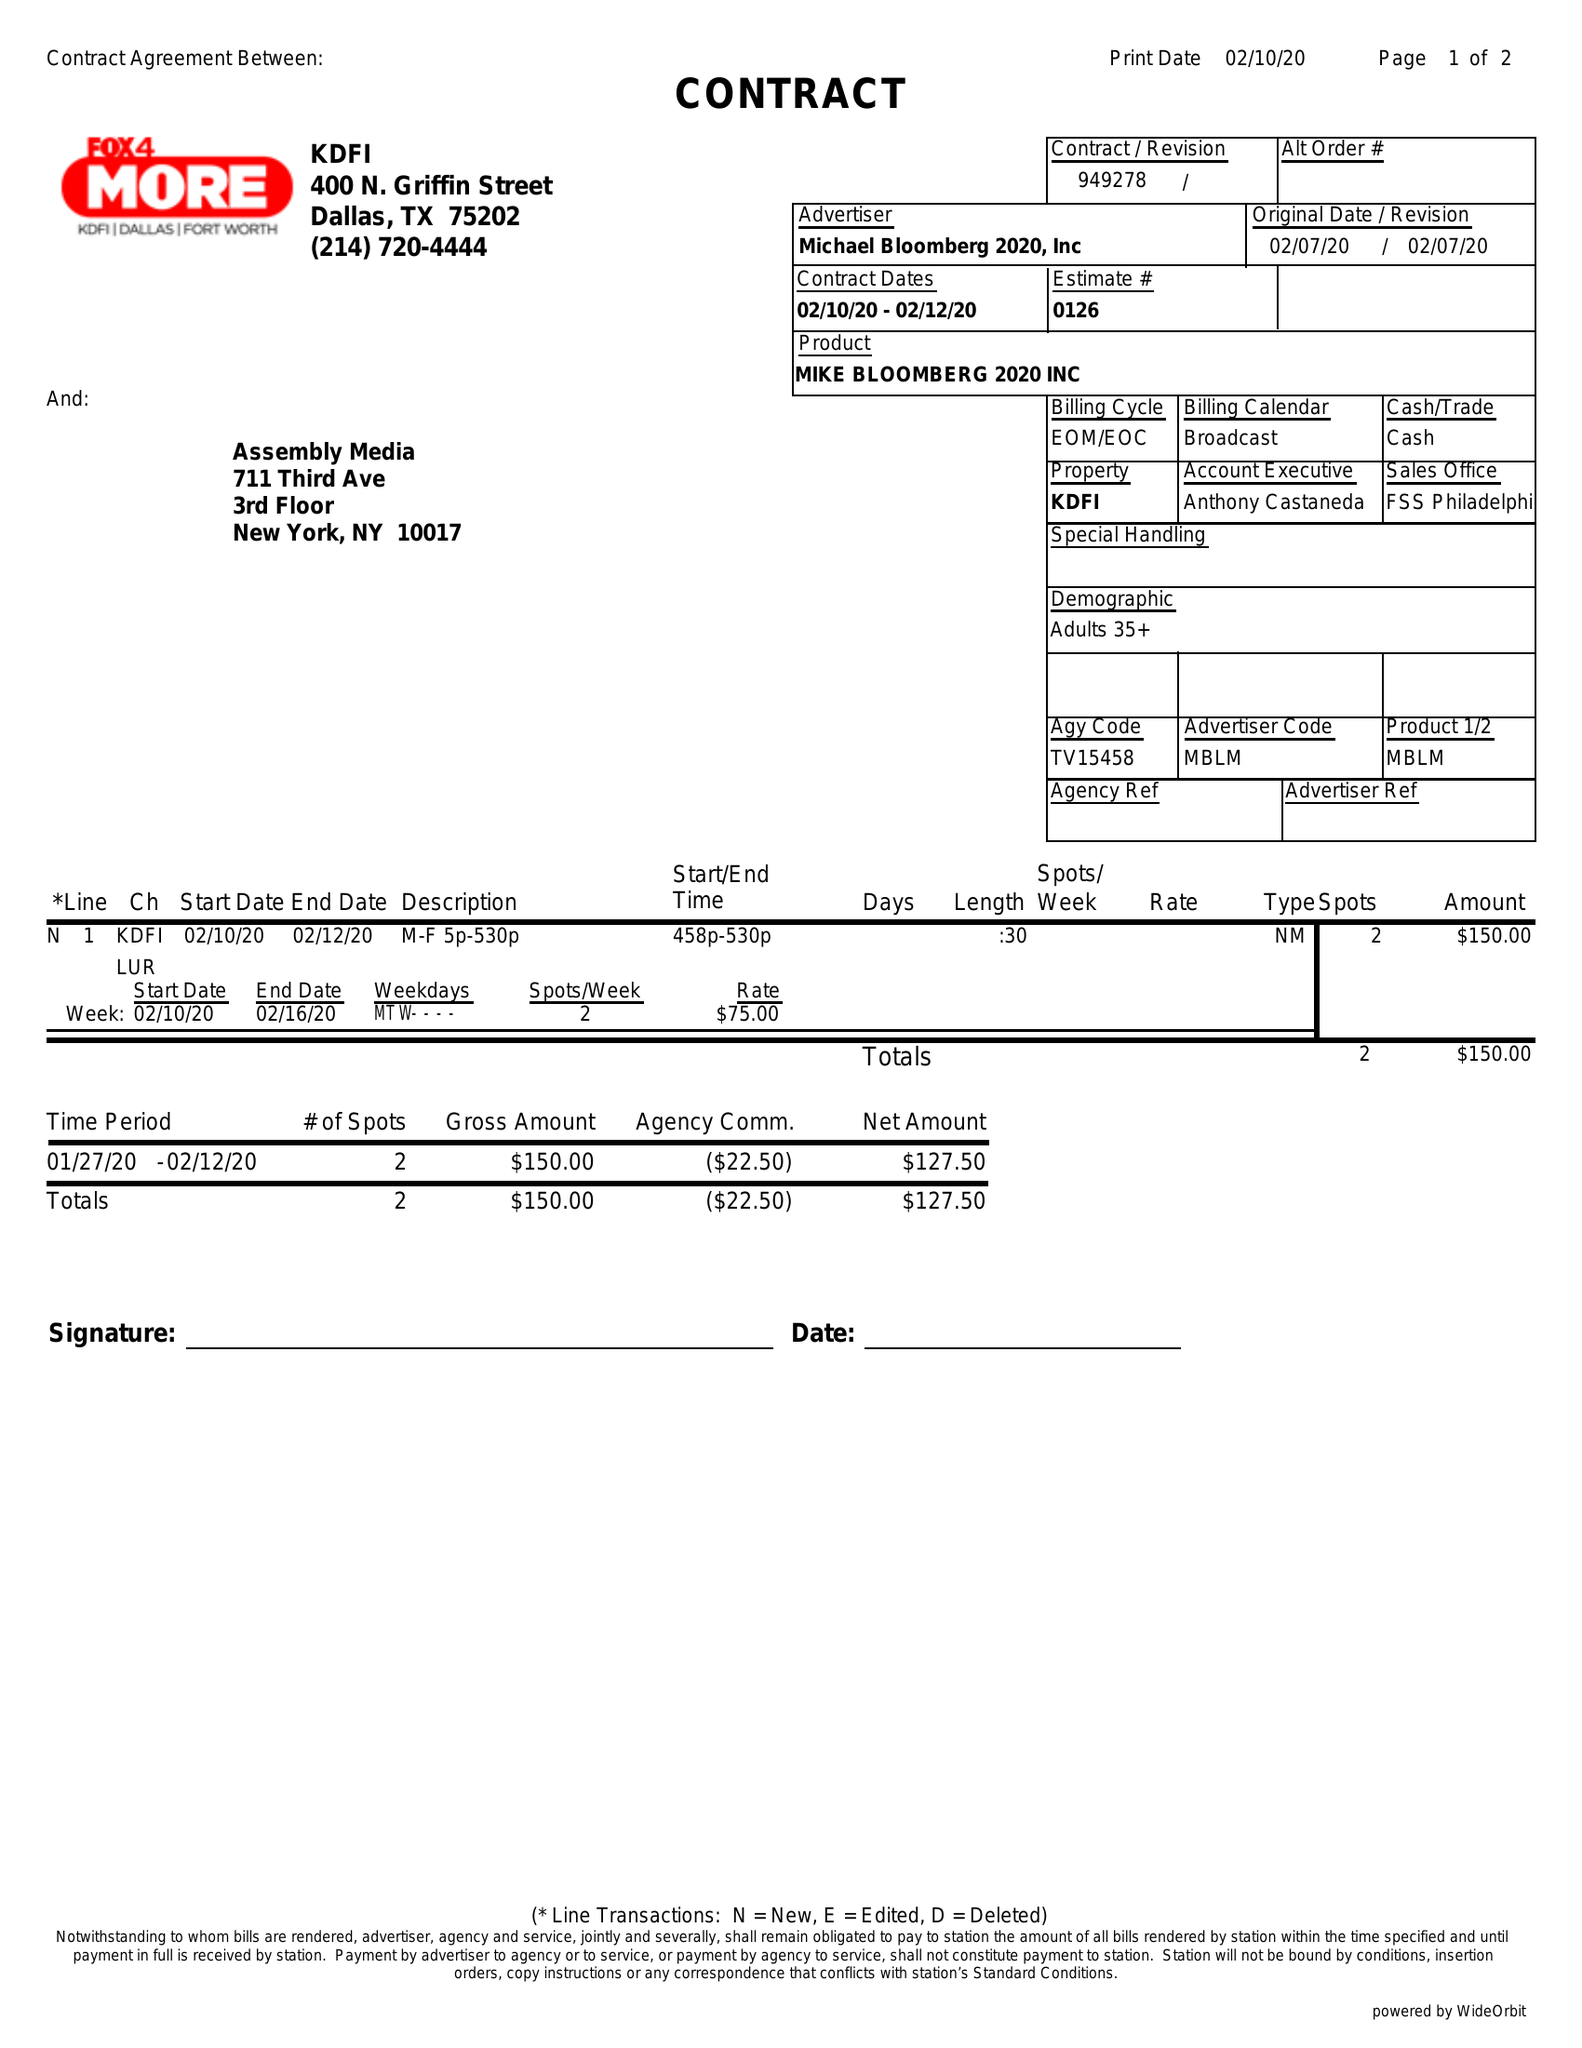What is the value for the flight_from?
Answer the question using a single word or phrase. 02/10/20 